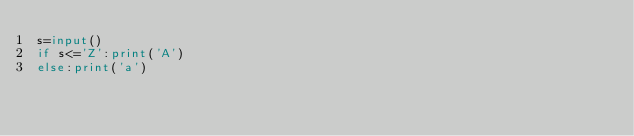Convert code to text. <code><loc_0><loc_0><loc_500><loc_500><_Python_>s=input()
if s<='Z':print('A')
else:print('a')</code> 